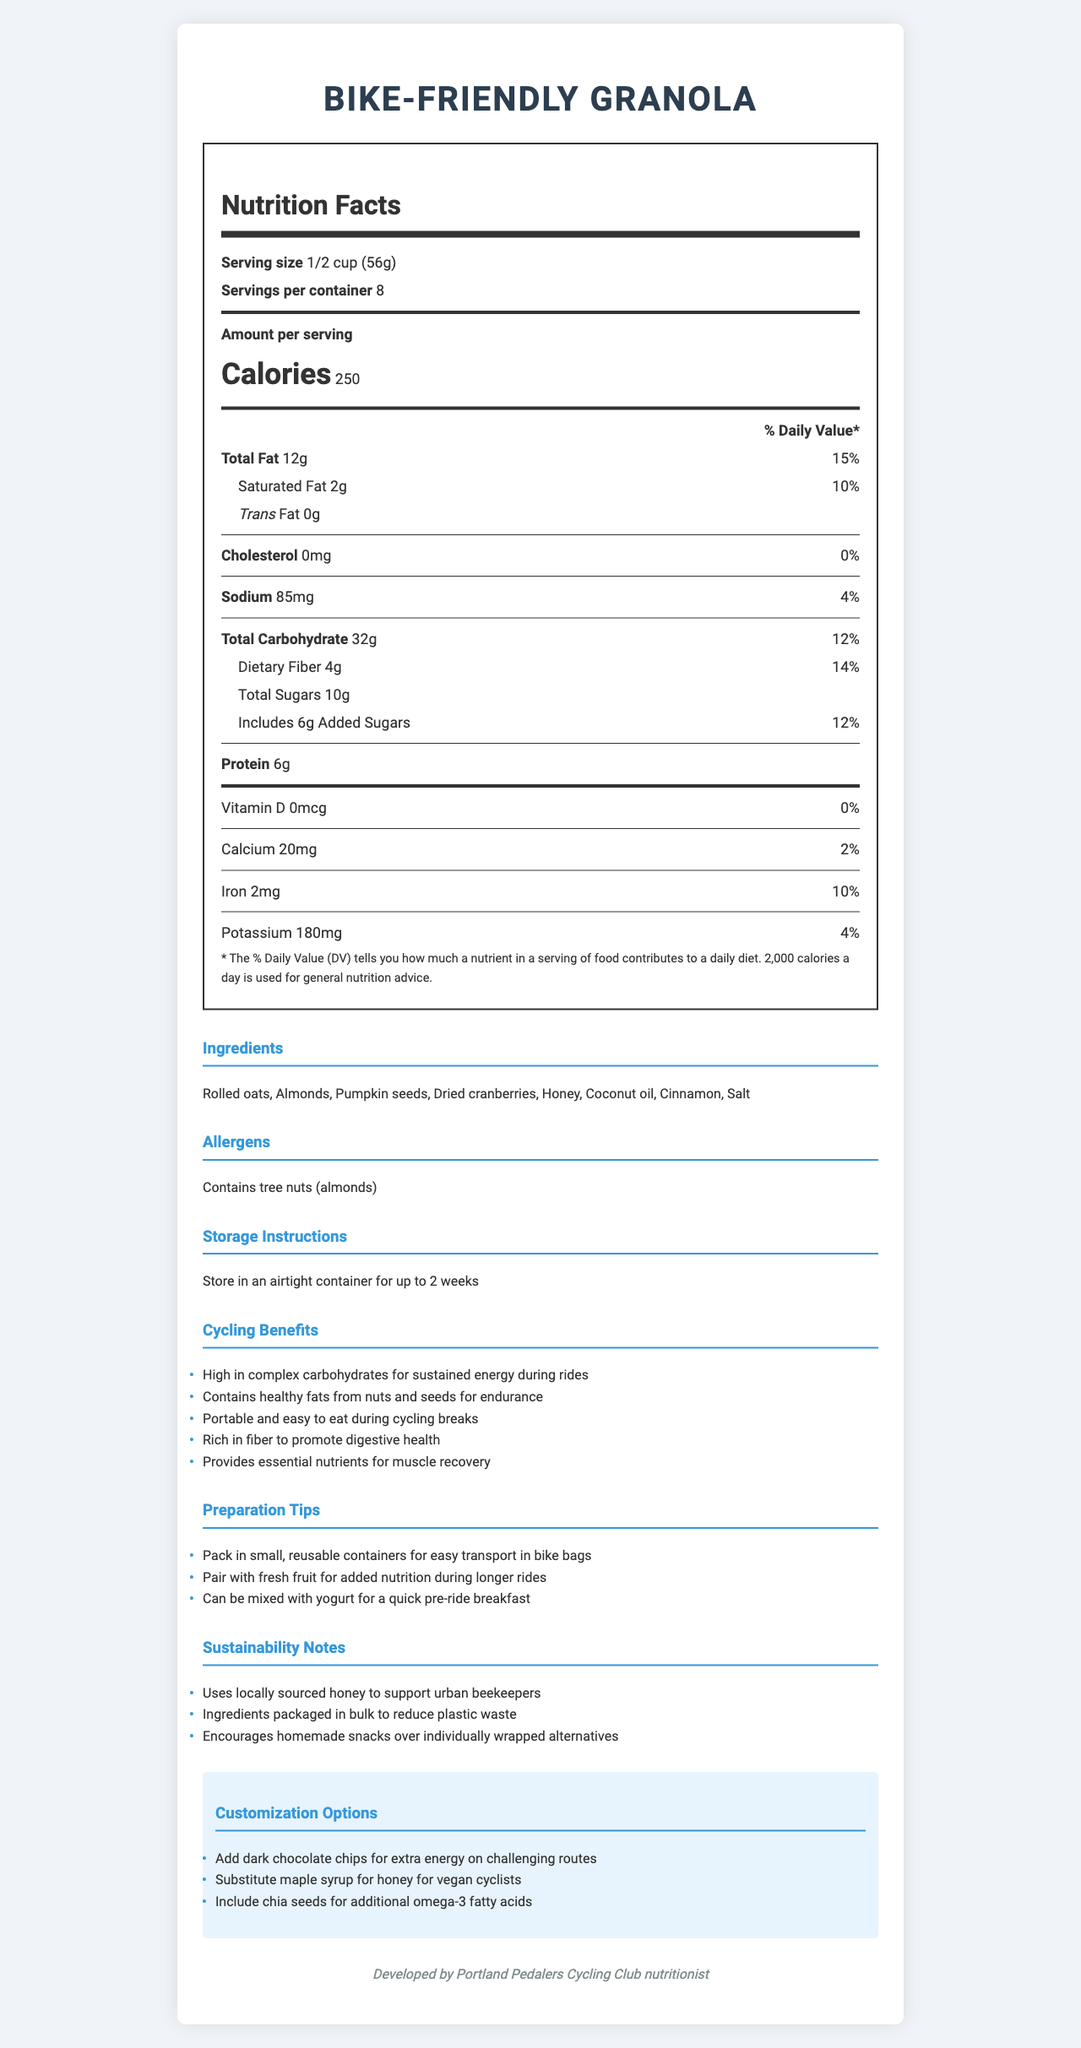what is the serving size for the granola? The serving size is clearly mentioned at the beginning of the Nutrition Facts label as "1/2 cup (56g)."
Answer: 1/2 cup (56g) how many servings are there per container? The information is noted as "Servings per container: 8" near the top of the document.
Answer: 8 how many calories are in one serving? The document shows "Calories 250" under the Amount per serving section.
Answer: 250 what is the total fat content per serving, and its % Daily Value? The total fat content is listed as "Total Fat 12g" with a "% Daily Value" of "15%" next to it.
Answer: 12g, 15% how much protein is in one serving? The protein content for one serving is explicitly mentioned as "Protein 6g" under the Nutrition Facts section.
Answer: 6g what are the potential allergens present in the granola? The allergens section notes that the granola "Contains tree nuts (almonds)."
Answer: Contains tree nuts (almonds) what are the added sugars in one serving and their % Daily Value? Under the Total Sugars section, it states "Includes 6g Added Sugars" with a "% Daily Value" of "12%."
Answer: 6g, 12% how much iron is in one serving and its % Daily Value? The iron content is shown as "Iron 2mg" with a "% Daily Value" of "10%" in the Nutrition Facts section.
Answer: 2mg, 10% which of the following is a storage instruction for the granola? A. Keep refrigerated B. Store in an airtight container for up to 2 weeks C. Freeze for long-term storage The storage instructions state, "Store in an airtight container for up to 2 weeks."
Answer: B. Store in an airtight container for up to 2 weeks what are some of the customization options for the granola? A. Add dark chocolate chips B. Include chia seeds C. Substitute maple syrup for honey D. All of the above The customization options include "Add dark chocolate chips", "Include chia seeds", and "Substitute maple syrup for honey."
Answer: D. All of the above is this granola high in complex carbohydrates, which provide sustained energy during rides? The cycling benefits section mentions that the granola is "High in complex carbohydrates for sustained energy during rides."
Answer: Yes summarize the main idea of this document. The document is comprehensive, covering various aspects of the granola, from nutritional values and ingredients to practical benefits for cyclists and ways to customize the recipe.
Answer: This document provides detailed nutrition facts and other relevant information for a homemade, bike-friendly granola recipe, including serving size, calorie content, ingredients, allergens, storage instructions, cycling benefits, preparation tips, and sustainability notes. The granola is designed to support the needs of cyclists by offering sustained energy, healthy fats, fiber, and essential nutrients for muscle recovery. where is the granola recipe origin mentioned? This information is mentioned at the bottom of the document, stating "Developed by Portland Pedalers Cycling Club nutritionist."
Answer: The recipe is developed by Portland Pedalers Cycling Club nutritionist can anyone with a nut allergy consume this granola? The allergens section clearly mentions that the granola "Contains tree nuts (almonds)," indicating it is not safe for those with a nut allergy.
Answer: No what is the amount of dietary fiber per serving, and its % Daily Value? The Nutrition Facts section shows "Dietary Fiber 4g" with a "% Daily Value" of "14%."
Answer: 4g, 14% what source of sweetener is mentioned in the ingredients? The list of ingredients includes "Honey" as the source of sweetener.
Answer: Honey can I substitute agave syrup for honey in this recipe? The customization options list substituting maple syrup for honey, but do not mention if agave syrup can be substituted.
Answer: Not enough information what is the % Daily Value of sodium per serving? The sodium content per serving is listed as "85mg" with a "% Daily Value" of "4%."
Answer: 4% how much calcium is in one serving and its daily value percentage? The document specifies "Calcium 20mg" with a "% Daily Value" of "2%."
Answer: 20mg, 2% how does the granola support urban bee-keeping? The sustainability notes mention that the granola "Uses locally sourced honey to support urban beekeepers."
Answer: Uses locally sourced honey 